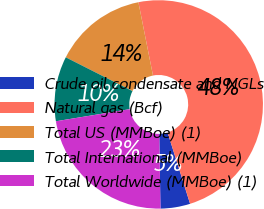Convert chart to OTSL. <chart><loc_0><loc_0><loc_500><loc_500><pie_chart><fcel>Crude oil condensate and NGLs<fcel>Natural gas (Bcf)<fcel>Total US (MMBoe) (1)<fcel>Total International (MMBoe)<fcel>Total Worldwide (MMBoe) (1)<nl><fcel>4.6%<fcel>48.26%<fcel>14.41%<fcel>10.05%<fcel>22.68%<nl></chart> 